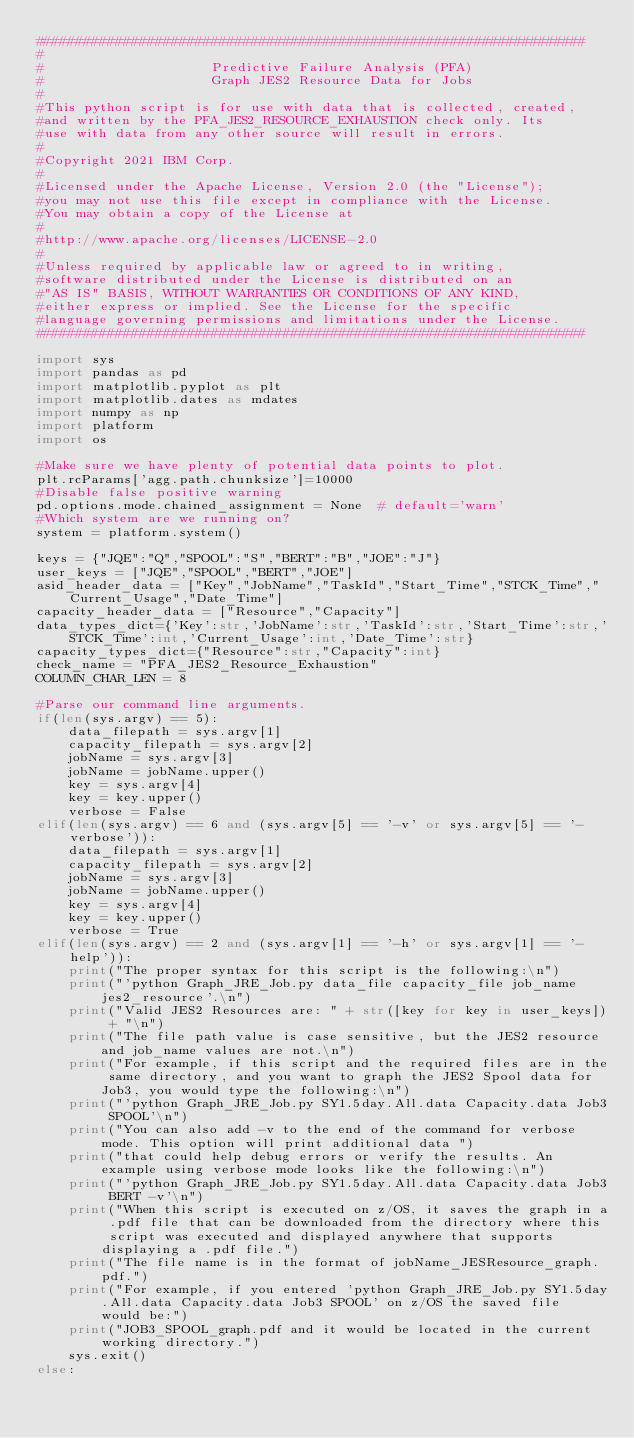Convert code to text. <code><loc_0><loc_0><loc_500><loc_500><_Python_>#####################################################################
#
#                     Predictive Failure Analysis (PFA)
#                     Graph JES2 Resource Data for Jobs
#
#This python script is for use with data that is collected, created,
#and written by the PFA_JES2_RESOURCE_EXHAUSTION check only. Its
#use with data from any other source will result in errors.
#
#Copyright 2021 IBM Corp.                                          
#                                                                   
#Licensed under the Apache License, Version 2.0 (the "License");   
#you may not use this file except in compliance with the License.  
#You may obtain a copy of the License at                           
#                                                                   
#http://www.apache.org/licenses/LICENSE-2.0                        
#                                                                   
#Unless required by applicable law or agreed to in writing,        
#software distributed under the License is distributed on an       
#"AS IS" BASIS, WITHOUT WARRANTIES OR CONDITIONS OF ANY KIND,      
#either express or implied. See the License for the specific       
#language governing permissions and limitations under the License. 
#####################################################################

import sys
import pandas as pd
import matplotlib.pyplot as plt
import matplotlib.dates as mdates
import numpy as np
import platform
import os

#Make sure we have plenty of potential data points to plot.
plt.rcParams['agg.path.chunksize']=10000
#Disable false positive warning
pd.options.mode.chained_assignment = None  # default='warn'
#Which system are we running on?
system = platform.system()

keys = {"JQE":"Q","SPOOL":"S","BERT":"B","JOE":"J"}
user_keys = ["JQE","SPOOL","BERT","JOE"]
asid_header_data = ["Key","JobName","TaskId","Start_Time","STCK_Time","Current_Usage","Date_Time"]
capacity_header_data = ["Resource","Capacity"]
data_types_dict={'Key':str,'JobName':str,'TaskId':str,'Start_Time':str,'STCK_Time':int,'Current_Usage':int,'Date_Time':str}
capacity_types_dict={"Resource":str,"Capacity":int}
check_name = "PFA_JES2_Resource_Exhaustion"
COLUMN_CHAR_LEN = 8

#Parse our command line arguments.
if(len(sys.argv) == 5):
    data_filepath = sys.argv[1]
    capacity_filepath = sys.argv[2]
    jobName = sys.argv[3]
    jobName = jobName.upper()
    key = sys.argv[4]
    key = key.upper()
    verbose = False
elif(len(sys.argv) == 6 and (sys.argv[5] == '-v' or sys.argv[5] == '-verbose')):
    data_filepath = sys.argv[1]
    capacity_filepath = sys.argv[2]    
    jobName = sys.argv[3]
    jobName = jobName.upper()
    key = sys.argv[4]
    key = key.upper()
    verbose = True
elif(len(sys.argv) == 2 and (sys.argv[1] == '-h' or sys.argv[1] == '-help')):
    print("The proper syntax for this script is the following:\n")
    print("'python Graph_JRE_Job.py data_file capacity_file job_name jes2_resource'.\n")
    print("Valid JES2 Resources are: " + str([key for key in user_keys]) + "\n")
    print("The file path value is case sensitive, but the JES2 resource and job_name values are not.\n")
    print("For example, if this script and the required files are in the same directory, and you want to graph the JES2 Spool data for Job3, you would type the following:\n")
    print("'python Graph_JRE_Job.py SY1.5day.All.data Capacity.data Job3 SPOOL'\n")
    print("You can also add -v to the end of the command for verbose mode. This option will print additional data ")
    print("that could help debug errors or verify the results. An example using verbose mode looks like the following:\n")
    print("'python Graph_JRE_Job.py SY1.5day.All.data Capacity.data Job3 BERT -v'\n")
    print("When this script is executed on z/OS, it saves the graph in a .pdf file that can be downloaded from the directory where this script was executed and displayed anywhere that supports displaying a .pdf file.")
    print("The file name is in the format of jobName_JESResource_graph.pdf.")
    print("For example, if you entered 'python Graph_JRE_Job.py SY1.5day.All.data Capacity.data Job3 SPOOL' on z/OS the saved file would be:")
    print("JOB3_SPOOL_graph.pdf and it would be located in the current working directory.")
    sys.exit()
else:</code> 